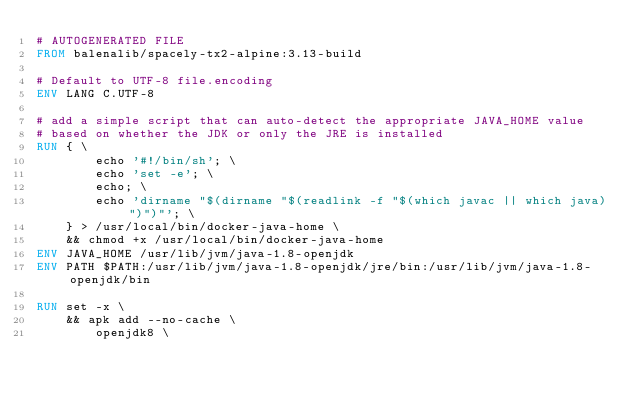<code> <loc_0><loc_0><loc_500><loc_500><_Dockerfile_># AUTOGENERATED FILE
FROM balenalib/spacely-tx2-alpine:3.13-build

# Default to UTF-8 file.encoding
ENV LANG C.UTF-8

# add a simple script that can auto-detect the appropriate JAVA_HOME value
# based on whether the JDK or only the JRE is installed
RUN { \
		echo '#!/bin/sh'; \
		echo 'set -e'; \
		echo; \
		echo 'dirname "$(dirname "$(readlink -f "$(which javac || which java)")")"'; \
	} > /usr/local/bin/docker-java-home \
	&& chmod +x /usr/local/bin/docker-java-home
ENV JAVA_HOME /usr/lib/jvm/java-1.8-openjdk
ENV PATH $PATH:/usr/lib/jvm/java-1.8-openjdk/jre/bin:/usr/lib/jvm/java-1.8-openjdk/bin

RUN set -x \
	&& apk add --no-cache \
		openjdk8 \</code> 